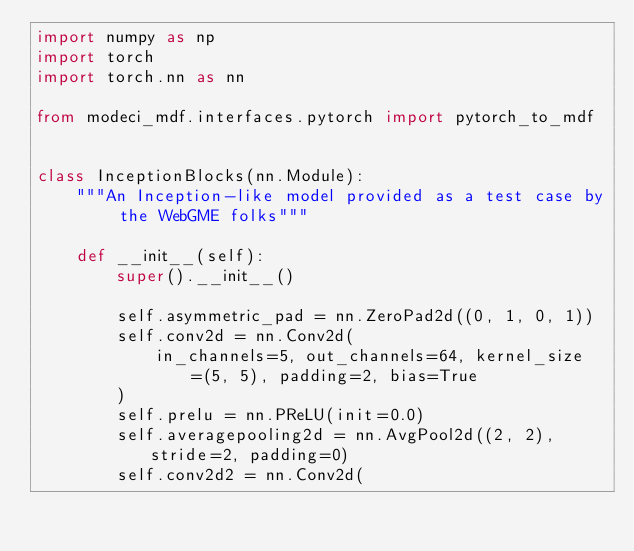Convert code to text. <code><loc_0><loc_0><loc_500><loc_500><_Python_>import numpy as np
import torch
import torch.nn as nn

from modeci_mdf.interfaces.pytorch import pytorch_to_mdf


class InceptionBlocks(nn.Module):
    """An Inception-like model provided as a test case by the WebGME folks"""

    def __init__(self):
        super().__init__()

        self.asymmetric_pad = nn.ZeroPad2d((0, 1, 0, 1))
        self.conv2d = nn.Conv2d(
            in_channels=5, out_channels=64, kernel_size=(5, 5), padding=2, bias=True
        )
        self.prelu = nn.PReLU(init=0.0)
        self.averagepooling2d = nn.AvgPool2d((2, 2), stride=2, padding=0)
        self.conv2d2 = nn.Conv2d(</code> 